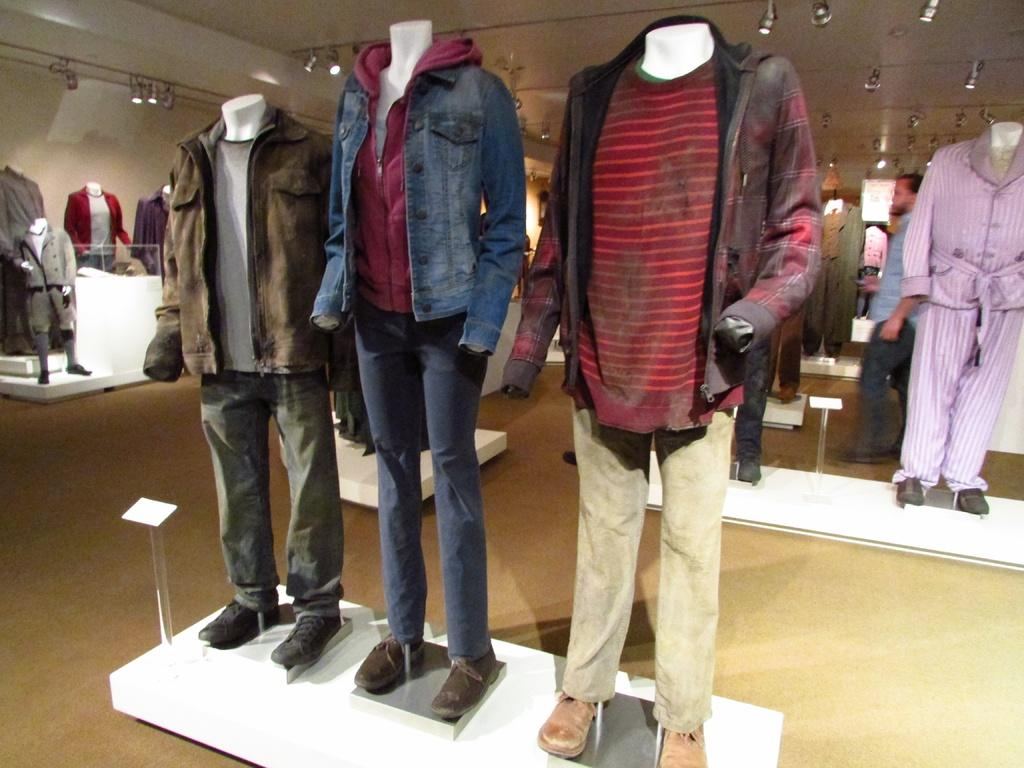What type of objects are dressed in the image? There are mannequins with dresses in the image. How are the mannequins positioned? The mannequins are on stands. What can be seen on the ceiling in the image? There are lights on the ceiling. Can you describe the presence of a person in the image? There is a person in the background of the image. How much income does the cloth in the image generate? There is no cloth generating income in the image; it features mannequins with dresses. What type of money is being used to purchase the mannequins in the image? There is no money or transaction depicted in the image; it only shows mannequins with dresses, stands, lights, and a person in the background. 